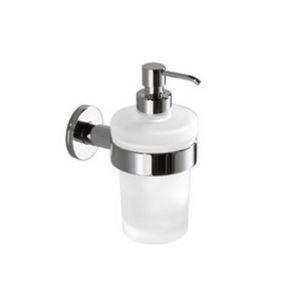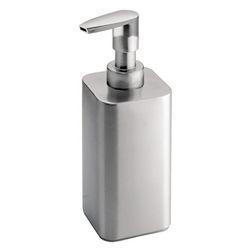The first image is the image on the left, the second image is the image on the right. Examine the images to the left and right. Is the description "One image shows a dispenser with a right-turned nozzle that mounts on the wall with a chrome band around it, and the other image shows a free-standing pump-top dispenser with a chrome top." accurate? Answer yes or no. Yes. 